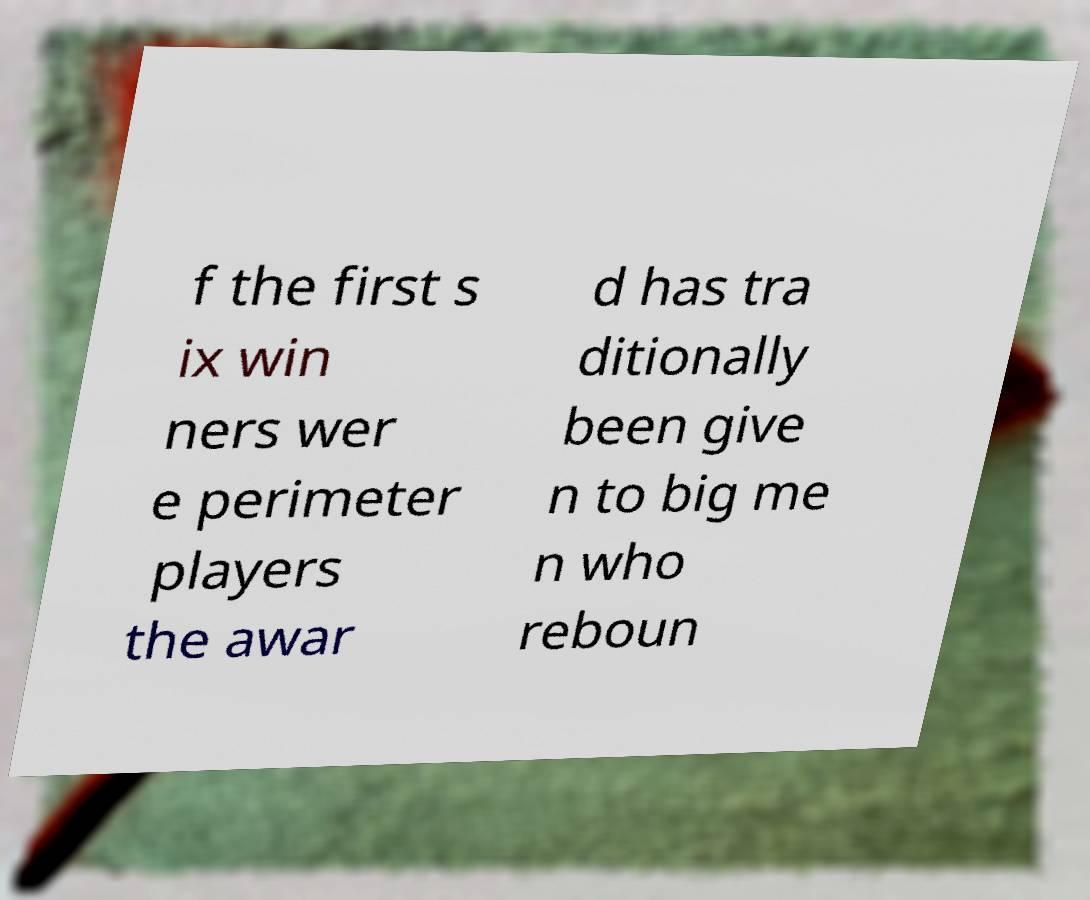For documentation purposes, I need the text within this image transcribed. Could you provide that? f the first s ix win ners wer e perimeter players the awar d has tra ditionally been give n to big me n who reboun 